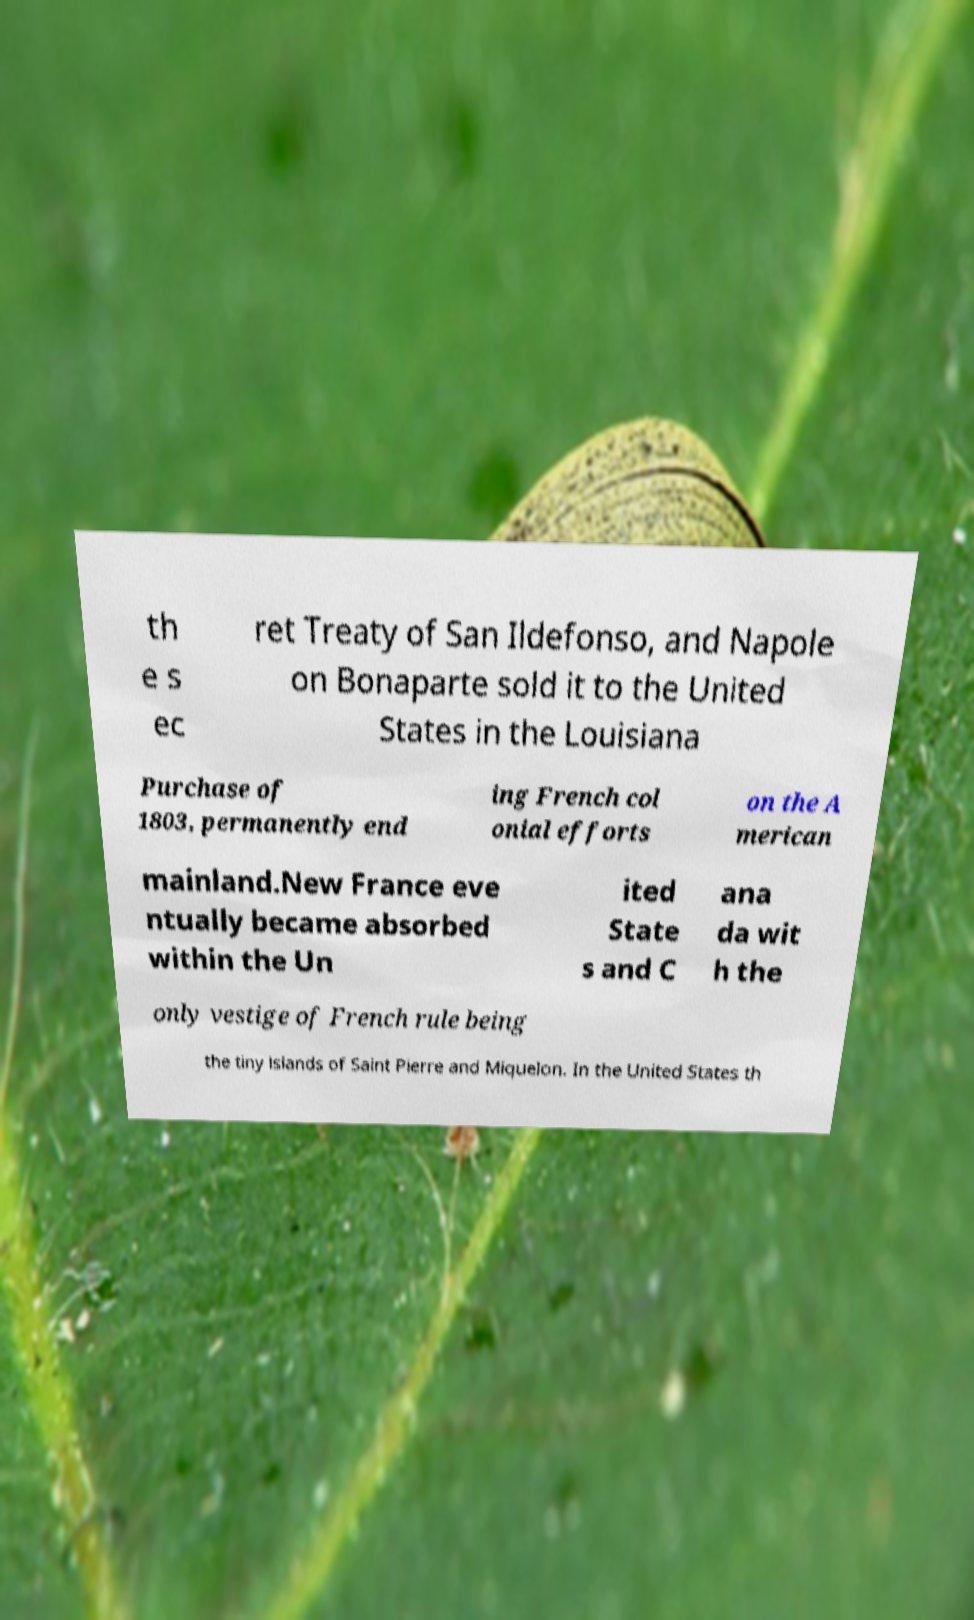There's text embedded in this image that I need extracted. Can you transcribe it verbatim? th e s ec ret Treaty of San Ildefonso, and Napole on Bonaparte sold it to the United States in the Louisiana Purchase of 1803, permanently end ing French col onial efforts on the A merican mainland.New France eve ntually became absorbed within the Un ited State s and C ana da wit h the only vestige of French rule being the tiny islands of Saint Pierre and Miquelon. In the United States th 